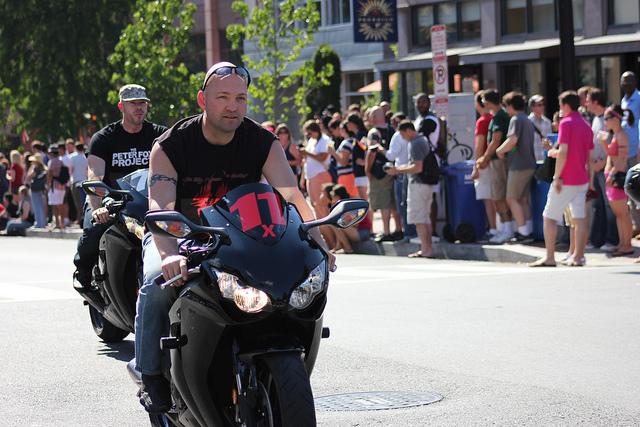Is the man wearing shades?
Concise answer only. Yes. What number is on the motorcycle?
Write a very short answer. 11. What are they riding on?
Short answer required. Motorcycles. 